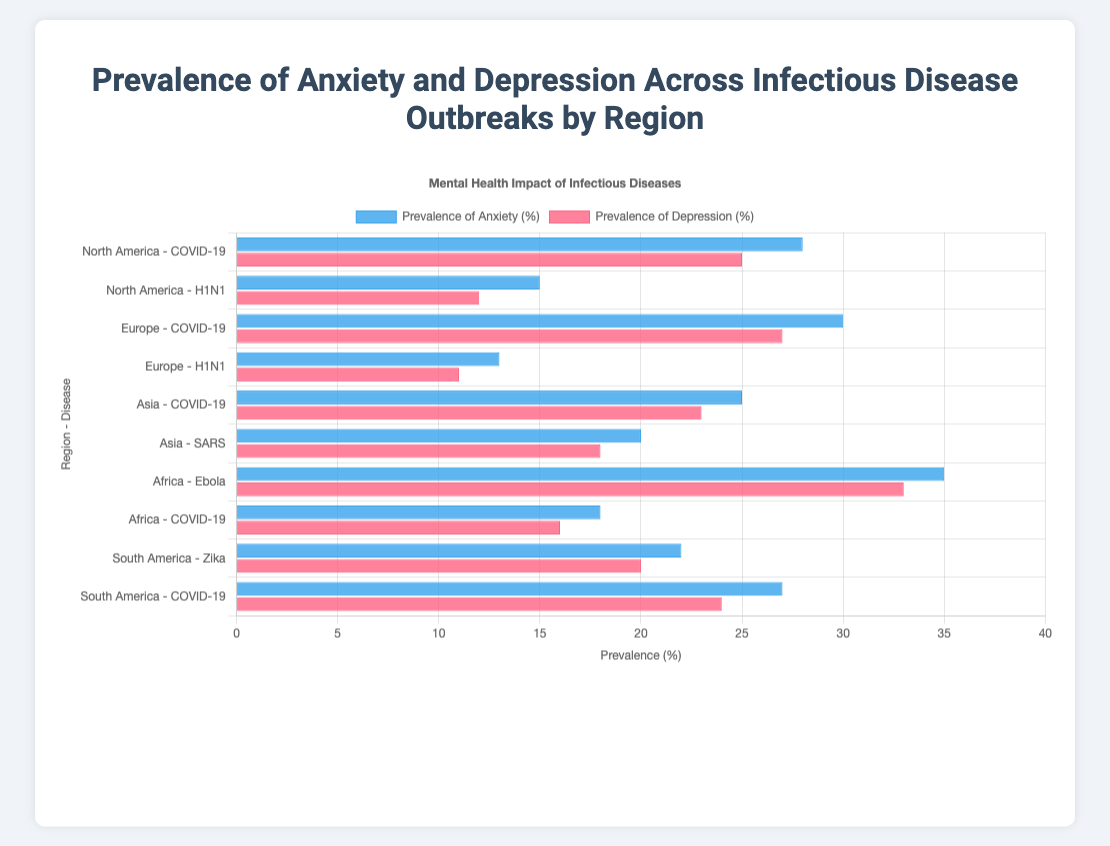What's the total prevalence of Anxiety across all regions and infectious diseases? Sum the prevalence of Anxiety values: 28 + 15 + 30 + 13 + 25 + 20 + 35 + 18 + 22 + 27 = 233
Answer: 233 Which region exhibits the highest prevalence of Depression for a single infectious disease, and what is the value? Identify the highest value in the prevalence of Depression: 33% in Africa for Ebola.
Answer: Africa, 33% What is the difference in the prevalence of Anxiety between North America during COVID-19 and H1N1? Subtract the prevalence of Anxiety during H1N1 from that during COVID-19 in North America: 28 - 15 = 13.
Answer: 13% Which disease in Europe has a higher prevalence of Depression, COVID-19 or H1N1, and by how much? Subtract the prevalence of Depression during H1N1 from that during COVID-19 in Europe: 27 - 11 = 16.
Answer: COVID-19, 16% What is the average prevalence of Depression in South America across the given infectious diseases? Sum the prevalence of Depression values for Zika and COVID-19 and divide by 2: (20 + 24) / 2 = 22.
Answer: 22% Which infectious disease shows a higher prevalence of Anxiety in Asia, COVID-19 or SARS? Compare the prevalence of Anxiety values: 25% for COVID-19, 20% for SARS.
Answer: COVID-19 What is the combined prevalence of Anxiety and Depression in Africa during the Ebola outbreak? Sum the prevalence values of Anxiety and Depression during Ebola in Africa: 35 + 33 = 68.
Answer: 68% Is the prevalence of Anxiety higher in North America or Europe during COVID-19, and by how much? Subtract the prevalence of Anxiety in North America from that in Europe during COVID-19: 30 - 28 = 2.
Answer: Europe, 2% What's the median prevalence of Anxiety across all regions and infectious diseases? Sort the values and find the middle value(s): 13, 15, 18, 20, 22, 25, 27, 28, 30, 35. The median is (25+27)/2 = 26.
Answer: 26% Which visual attribute distinguishes the anxiety data bars from the depression data bars? The bars representing Anxiety data are blue, whereas the bars representing Depression data are red.
Answer: Color 